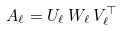<formula> <loc_0><loc_0><loc_500><loc_500>A _ { \ell } = U _ { \ell } \, W _ { \ell } \, V _ { \ell } ^ { \top }</formula> 